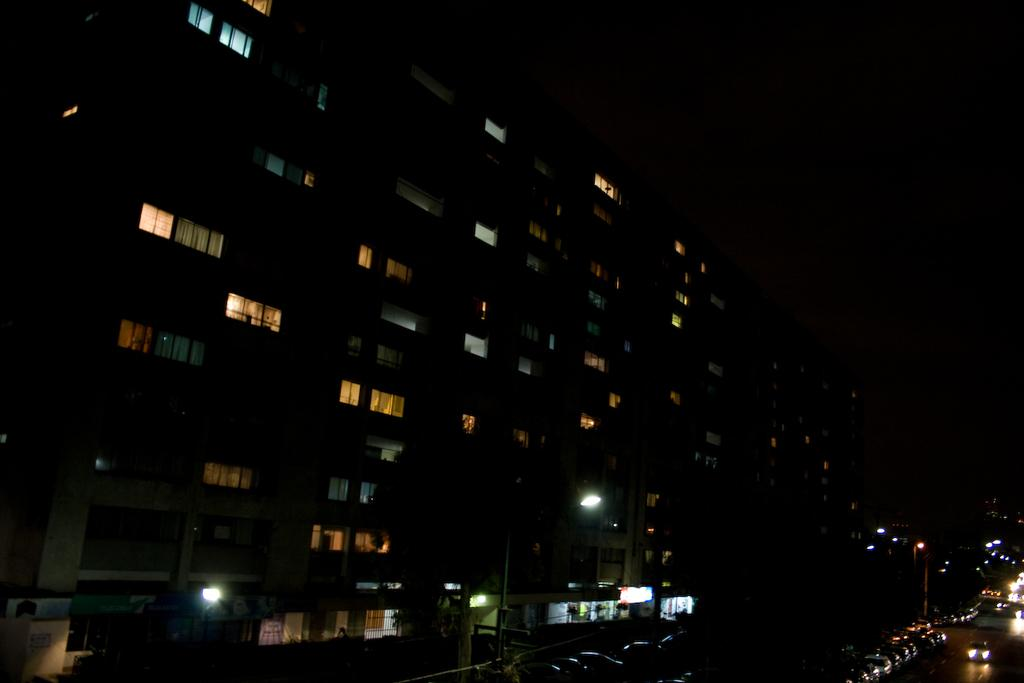What type of structure is visible in the image? There is a building in the image. What feature can be seen on the building? The building has windows. What else can be seen on the road in the image? There are vehicles on the road in the image. What are the tall, vertical objects in the image? There are light poles in the image. How would you describe the sky in the image? The sky is dark in the image. What type of creature can be seen crawling on the base of the building in the image? There is no creature visible in the image, and there is no mention of a base for the building. 